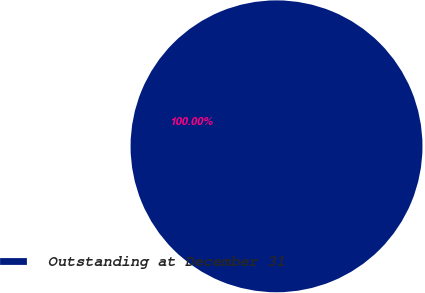<chart> <loc_0><loc_0><loc_500><loc_500><pie_chart><fcel>Outstanding at December 31<nl><fcel>100.0%<nl></chart> 